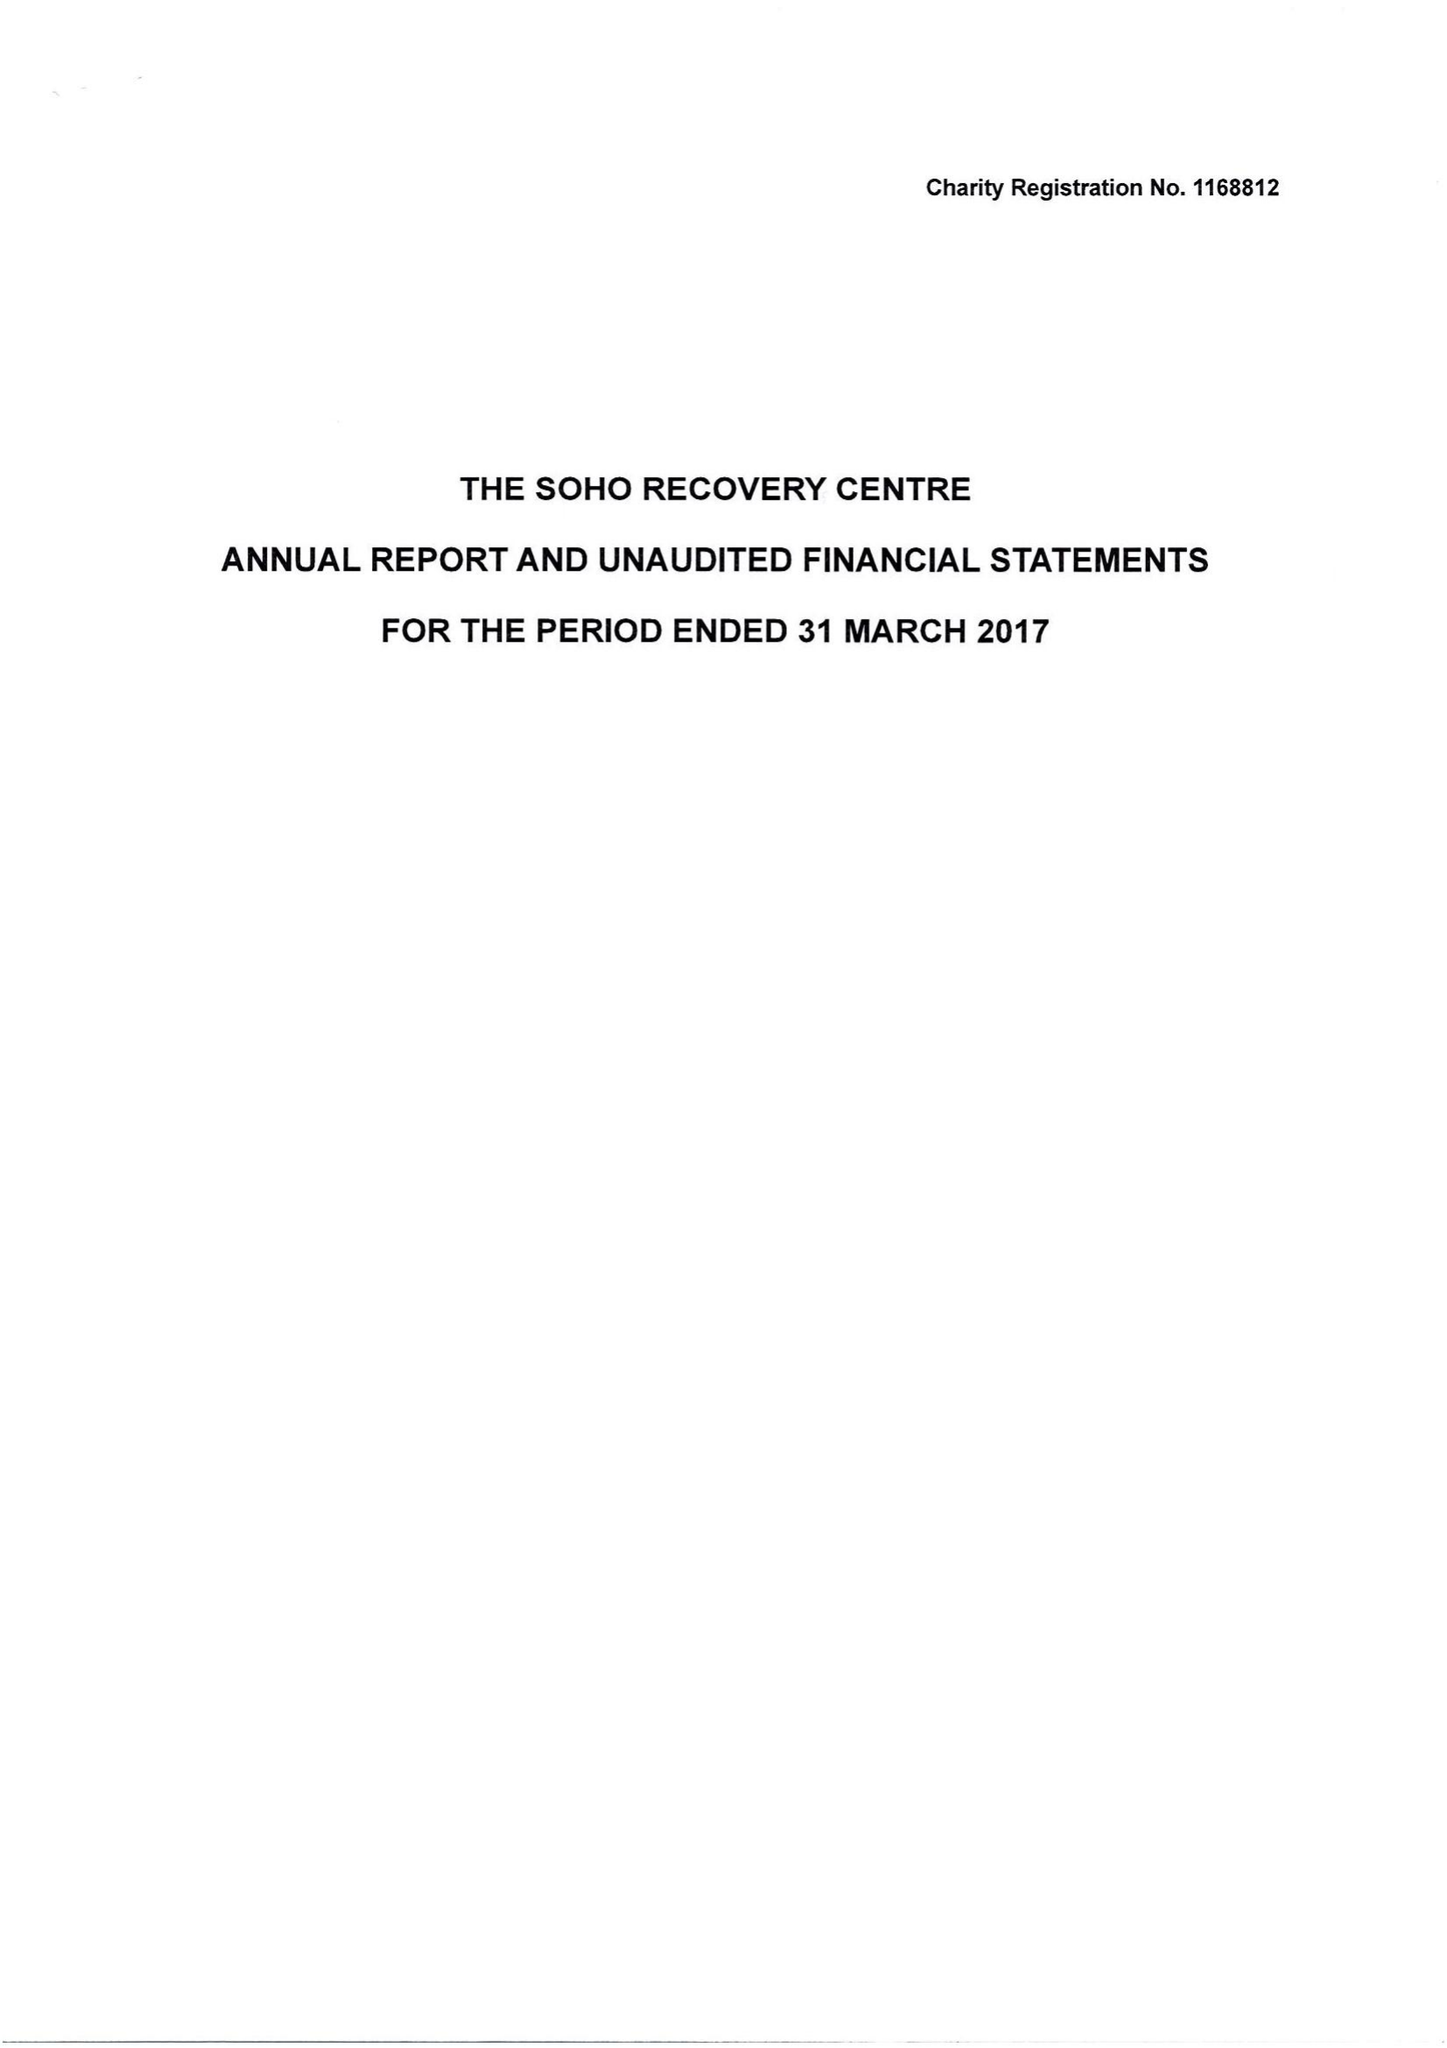What is the value for the charity_name?
Answer the question using a single word or phrase. The Soho Recovery Centre 